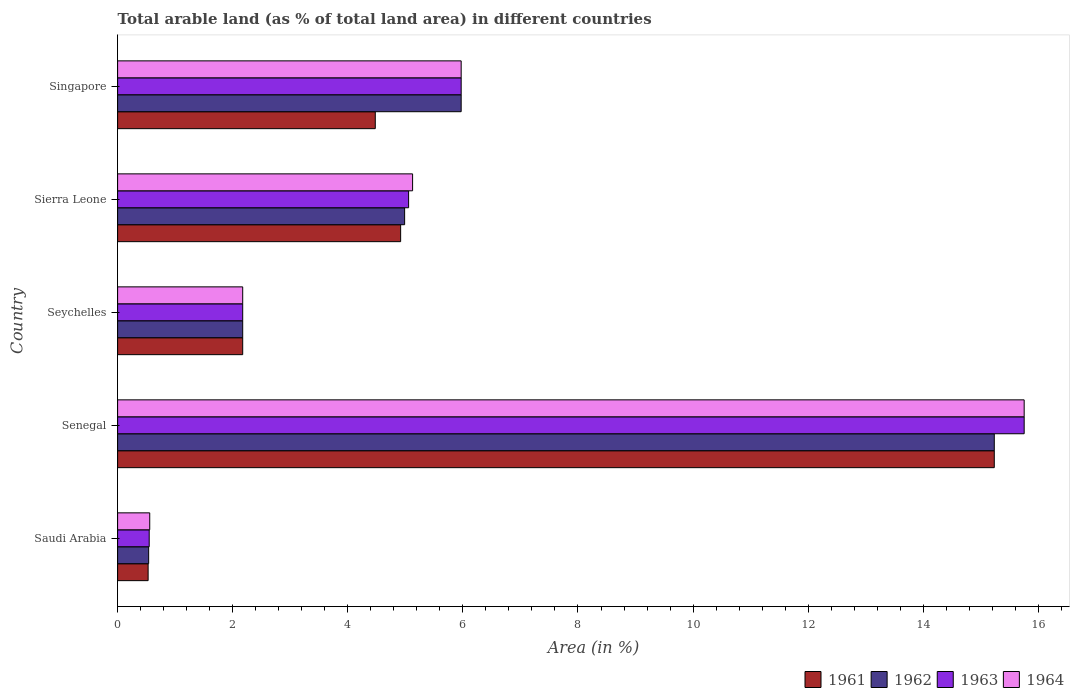How many different coloured bars are there?
Your answer should be compact. 4. Are the number of bars on each tick of the Y-axis equal?
Your answer should be compact. Yes. How many bars are there on the 1st tick from the bottom?
Provide a short and direct response. 4. What is the label of the 5th group of bars from the top?
Keep it short and to the point. Saudi Arabia. In how many cases, is the number of bars for a given country not equal to the number of legend labels?
Provide a succinct answer. 0. What is the percentage of arable land in 1962 in Saudi Arabia?
Your answer should be compact. 0.54. Across all countries, what is the maximum percentage of arable land in 1962?
Offer a very short reply. 15.23. Across all countries, what is the minimum percentage of arable land in 1961?
Offer a terse response. 0.53. In which country was the percentage of arable land in 1962 maximum?
Offer a very short reply. Senegal. In which country was the percentage of arable land in 1961 minimum?
Offer a very short reply. Saudi Arabia. What is the total percentage of arable land in 1964 in the graph?
Offer a very short reply. 29.58. What is the difference between the percentage of arable land in 1961 in Senegal and that in Singapore?
Your answer should be compact. 10.76. What is the difference between the percentage of arable land in 1961 in Senegal and the percentage of arable land in 1962 in Singapore?
Offer a terse response. 9.26. What is the average percentage of arable land in 1964 per country?
Your answer should be very brief. 5.92. What is the difference between the percentage of arable land in 1963 and percentage of arable land in 1964 in Senegal?
Offer a very short reply. 0. What is the ratio of the percentage of arable land in 1961 in Seychelles to that in Sierra Leone?
Offer a very short reply. 0.44. What is the difference between the highest and the second highest percentage of arable land in 1961?
Your answer should be compact. 10.32. What is the difference between the highest and the lowest percentage of arable land in 1964?
Keep it short and to the point. 15.2. Is the sum of the percentage of arable land in 1963 in Saudi Arabia and Seychelles greater than the maximum percentage of arable land in 1962 across all countries?
Offer a very short reply. No. What does the 1st bar from the bottom in Seychelles represents?
Ensure brevity in your answer.  1961. What is the difference between two consecutive major ticks on the X-axis?
Your answer should be very brief. 2. Does the graph contain any zero values?
Your answer should be compact. No. Does the graph contain grids?
Keep it short and to the point. No. Where does the legend appear in the graph?
Ensure brevity in your answer.  Bottom right. How many legend labels are there?
Give a very brief answer. 4. What is the title of the graph?
Offer a terse response. Total arable land (as % of total land area) in different countries. What is the label or title of the X-axis?
Your answer should be very brief. Area (in %). What is the Area (in %) in 1961 in Saudi Arabia?
Your answer should be very brief. 0.53. What is the Area (in %) in 1962 in Saudi Arabia?
Give a very brief answer. 0.54. What is the Area (in %) of 1963 in Saudi Arabia?
Offer a very short reply. 0.55. What is the Area (in %) of 1964 in Saudi Arabia?
Keep it short and to the point. 0.56. What is the Area (in %) in 1961 in Senegal?
Keep it short and to the point. 15.23. What is the Area (in %) of 1962 in Senegal?
Your answer should be very brief. 15.23. What is the Area (in %) in 1963 in Senegal?
Your response must be concise. 15.75. What is the Area (in %) in 1964 in Senegal?
Ensure brevity in your answer.  15.75. What is the Area (in %) of 1961 in Seychelles?
Give a very brief answer. 2.17. What is the Area (in %) of 1962 in Seychelles?
Your answer should be very brief. 2.17. What is the Area (in %) of 1963 in Seychelles?
Your answer should be very brief. 2.17. What is the Area (in %) of 1964 in Seychelles?
Your response must be concise. 2.17. What is the Area (in %) in 1961 in Sierra Leone?
Ensure brevity in your answer.  4.92. What is the Area (in %) in 1962 in Sierra Leone?
Provide a short and direct response. 4.99. What is the Area (in %) of 1963 in Sierra Leone?
Give a very brief answer. 5.06. What is the Area (in %) of 1964 in Sierra Leone?
Your answer should be very brief. 5.13. What is the Area (in %) of 1961 in Singapore?
Offer a very short reply. 4.48. What is the Area (in %) of 1962 in Singapore?
Make the answer very short. 5.97. What is the Area (in %) in 1963 in Singapore?
Provide a succinct answer. 5.97. What is the Area (in %) of 1964 in Singapore?
Provide a succinct answer. 5.97. Across all countries, what is the maximum Area (in %) in 1961?
Your response must be concise. 15.23. Across all countries, what is the maximum Area (in %) of 1962?
Keep it short and to the point. 15.23. Across all countries, what is the maximum Area (in %) in 1963?
Offer a terse response. 15.75. Across all countries, what is the maximum Area (in %) in 1964?
Your response must be concise. 15.75. Across all countries, what is the minimum Area (in %) of 1961?
Give a very brief answer. 0.53. Across all countries, what is the minimum Area (in %) in 1962?
Your answer should be very brief. 0.54. Across all countries, what is the minimum Area (in %) of 1963?
Give a very brief answer. 0.55. Across all countries, what is the minimum Area (in %) of 1964?
Your answer should be compact. 0.56. What is the total Area (in %) in 1961 in the graph?
Keep it short and to the point. 27.33. What is the total Area (in %) in 1962 in the graph?
Give a very brief answer. 28.91. What is the total Area (in %) in 1963 in the graph?
Your answer should be compact. 29.5. What is the total Area (in %) in 1964 in the graph?
Keep it short and to the point. 29.58. What is the difference between the Area (in %) of 1961 in Saudi Arabia and that in Senegal?
Offer a terse response. -14.7. What is the difference between the Area (in %) in 1962 in Saudi Arabia and that in Senegal?
Give a very brief answer. -14.69. What is the difference between the Area (in %) in 1963 in Saudi Arabia and that in Senegal?
Ensure brevity in your answer.  -15.2. What is the difference between the Area (in %) of 1964 in Saudi Arabia and that in Senegal?
Provide a succinct answer. -15.2. What is the difference between the Area (in %) of 1961 in Saudi Arabia and that in Seychelles?
Make the answer very short. -1.64. What is the difference between the Area (in %) of 1962 in Saudi Arabia and that in Seychelles?
Keep it short and to the point. -1.63. What is the difference between the Area (in %) in 1963 in Saudi Arabia and that in Seychelles?
Your answer should be very brief. -1.62. What is the difference between the Area (in %) of 1964 in Saudi Arabia and that in Seychelles?
Your answer should be very brief. -1.62. What is the difference between the Area (in %) of 1961 in Saudi Arabia and that in Sierra Leone?
Make the answer very short. -4.39. What is the difference between the Area (in %) in 1962 in Saudi Arabia and that in Sierra Leone?
Offer a terse response. -4.45. What is the difference between the Area (in %) of 1963 in Saudi Arabia and that in Sierra Leone?
Provide a succinct answer. -4.51. What is the difference between the Area (in %) of 1964 in Saudi Arabia and that in Sierra Leone?
Ensure brevity in your answer.  -4.57. What is the difference between the Area (in %) in 1961 in Saudi Arabia and that in Singapore?
Offer a terse response. -3.95. What is the difference between the Area (in %) of 1962 in Saudi Arabia and that in Singapore?
Provide a succinct answer. -5.43. What is the difference between the Area (in %) in 1963 in Saudi Arabia and that in Singapore?
Your response must be concise. -5.42. What is the difference between the Area (in %) of 1964 in Saudi Arabia and that in Singapore?
Your answer should be compact. -5.41. What is the difference between the Area (in %) of 1961 in Senegal and that in Seychelles?
Keep it short and to the point. 13.06. What is the difference between the Area (in %) in 1962 in Senegal and that in Seychelles?
Your answer should be compact. 13.06. What is the difference between the Area (in %) of 1963 in Senegal and that in Seychelles?
Offer a terse response. 13.58. What is the difference between the Area (in %) in 1964 in Senegal and that in Seychelles?
Your answer should be very brief. 13.58. What is the difference between the Area (in %) of 1961 in Senegal and that in Sierra Leone?
Offer a terse response. 10.32. What is the difference between the Area (in %) in 1962 in Senegal and that in Sierra Leone?
Provide a succinct answer. 10.25. What is the difference between the Area (in %) in 1963 in Senegal and that in Sierra Leone?
Provide a short and direct response. 10.7. What is the difference between the Area (in %) in 1964 in Senegal and that in Sierra Leone?
Ensure brevity in your answer.  10.63. What is the difference between the Area (in %) of 1961 in Senegal and that in Singapore?
Offer a terse response. 10.76. What is the difference between the Area (in %) of 1962 in Senegal and that in Singapore?
Ensure brevity in your answer.  9.26. What is the difference between the Area (in %) in 1963 in Senegal and that in Singapore?
Your answer should be very brief. 9.78. What is the difference between the Area (in %) in 1964 in Senegal and that in Singapore?
Your answer should be compact. 9.78. What is the difference between the Area (in %) in 1961 in Seychelles and that in Sierra Leone?
Offer a terse response. -2.74. What is the difference between the Area (in %) in 1962 in Seychelles and that in Sierra Leone?
Offer a very short reply. -2.81. What is the difference between the Area (in %) of 1963 in Seychelles and that in Sierra Leone?
Give a very brief answer. -2.88. What is the difference between the Area (in %) of 1964 in Seychelles and that in Sierra Leone?
Your response must be concise. -2.95. What is the difference between the Area (in %) in 1961 in Seychelles and that in Singapore?
Offer a terse response. -2.3. What is the difference between the Area (in %) of 1962 in Seychelles and that in Singapore?
Give a very brief answer. -3.8. What is the difference between the Area (in %) in 1963 in Seychelles and that in Singapore?
Keep it short and to the point. -3.8. What is the difference between the Area (in %) in 1964 in Seychelles and that in Singapore?
Your answer should be compact. -3.8. What is the difference between the Area (in %) of 1961 in Sierra Leone and that in Singapore?
Give a very brief answer. 0.44. What is the difference between the Area (in %) in 1962 in Sierra Leone and that in Singapore?
Make the answer very short. -0.98. What is the difference between the Area (in %) in 1963 in Sierra Leone and that in Singapore?
Keep it short and to the point. -0.91. What is the difference between the Area (in %) in 1964 in Sierra Leone and that in Singapore?
Offer a very short reply. -0.84. What is the difference between the Area (in %) in 1961 in Saudi Arabia and the Area (in %) in 1962 in Senegal?
Your response must be concise. -14.7. What is the difference between the Area (in %) of 1961 in Saudi Arabia and the Area (in %) of 1963 in Senegal?
Offer a very short reply. -15.22. What is the difference between the Area (in %) in 1961 in Saudi Arabia and the Area (in %) in 1964 in Senegal?
Make the answer very short. -15.22. What is the difference between the Area (in %) in 1962 in Saudi Arabia and the Area (in %) in 1963 in Senegal?
Your response must be concise. -15.21. What is the difference between the Area (in %) in 1962 in Saudi Arabia and the Area (in %) in 1964 in Senegal?
Give a very brief answer. -15.21. What is the difference between the Area (in %) in 1963 in Saudi Arabia and the Area (in %) in 1964 in Senegal?
Offer a very short reply. -15.2. What is the difference between the Area (in %) of 1961 in Saudi Arabia and the Area (in %) of 1962 in Seychelles?
Your answer should be compact. -1.64. What is the difference between the Area (in %) of 1961 in Saudi Arabia and the Area (in %) of 1963 in Seychelles?
Ensure brevity in your answer.  -1.64. What is the difference between the Area (in %) of 1961 in Saudi Arabia and the Area (in %) of 1964 in Seychelles?
Make the answer very short. -1.64. What is the difference between the Area (in %) of 1962 in Saudi Arabia and the Area (in %) of 1963 in Seychelles?
Keep it short and to the point. -1.63. What is the difference between the Area (in %) of 1962 in Saudi Arabia and the Area (in %) of 1964 in Seychelles?
Provide a succinct answer. -1.63. What is the difference between the Area (in %) of 1963 in Saudi Arabia and the Area (in %) of 1964 in Seychelles?
Provide a succinct answer. -1.62. What is the difference between the Area (in %) of 1961 in Saudi Arabia and the Area (in %) of 1962 in Sierra Leone?
Offer a terse response. -4.46. What is the difference between the Area (in %) of 1961 in Saudi Arabia and the Area (in %) of 1963 in Sierra Leone?
Your answer should be very brief. -4.53. What is the difference between the Area (in %) in 1961 in Saudi Arabia and the Area (in %) in 1964 in Sierra Leone?
Offer a terse response. -4.6. What is the difference between the Area (in %) of 1962 in Saudi Arabia and the Area (in %) of 1963 in Sierra Leone?
Offer a terse response. -4.52. What is the difference between the Area (in %) in 1962 in Saudi Arabia and the Area (in %) in 1964 in Sierra Leone?
Make the answer very short. -4.59. What is the difference between the Area (in %) in 1963 in Saudi Arabia and the Area (in %) in 1964 in Sierra Leone?
Give a very brief answer. -4.58. What is the difference between the Area (in %) of 1961 in Saudi Arabia and the Area (in %) of 1962 in Singapore?
Your answer should be very brief. -5.44. What is the difference between the Area (in %) in 1961 in Saudi Arabia and the Area (in %) in 1963 in Singapore?
Make the answer very short. -5.44. What is the difference between the Area (in %) of 1961 in Saudi Arabia and the Area (in %) of 1964 in Singapore?
Your answer should be very brief. -5.44. What is the difference between the Area (in %) in 1962 in Saudi Arabia and the Area (in %) in 1963 in Singapore?
Ensure brevity in your answer.  -5.43. What is the difference between the Area (in %) of 1962 in Saudi Arabia and the Area (in %) of 1964 in Singapore?
Ensure brevity in your answer.  -5.43. What is the difference between the Area (in %) of 1963 in Saudi Arabia and the Area (in %) of 1964 in Singapore?
Make the answer very short. -5.42. What is the difference between the Area (in %) in 1961 in Senegal and the Area (in %) in 1962 in Seychelles?
Give a very brief answer. 13.06. What is the difference between the Area (in %) in 1961 in Senegal and the Area (in %) in 1963 in Seychelles?
Make the answer very short. 13.06. What is the difference between the Area (in %) of 1961 in Senegal and the Area (in %) of 1964 in Seychelles?
Provide a short and direct response. 13.06. What is the difference between the Area (in %) of 1962 in Senegal and the Area (in %) of 1963 in Seychelles?
Provide a succinct answer. 13.06. What is the difference between the Area (in %) of 1962 in Senegal and the Area (in %) of 1964 in Seychelles?
Your response must be concise. 13.06. What is the difference between the Area (in %) in 1963 in Senegal and the Area (in %) in 1964 in Seychelles?
Your answer should be very brief. 13.58. What is the difference between the Area (in %) in 1961 in Senegal and the Area (in %) in 1962 in Sierra Leone?
Your answer should be very brief. 10.25. What is the difference between the Area (in %) in 1961 in Senegal and the Area (in %) in 1963 in Sierra Leone?
Your answer should be very brief. 10.18. What is the difference between the Area (in %) of 1961 in Senegal and the Area (in %) of 1964 in Sierra Leone?
Offer a terse response. 10.11. What is the difference between the Area (in %) in 1962 in Senegal and the Area (in %) in 1963 in Sierra Leone?
Your answer should be compact. 10.18. What is the difference between the Area (in %) of 1962 in Senegal and the Area (in %) of 1964 in Sierra Leone?
Keep it short and to the point. 10.11. What is the difference between the Area (in %) of 1963 in Senegal and the Area (in %) of 1964 in Sierra Leone?
Ensure brevity in your answer.  10.63. What is the difference between the Area (in %) in 1961 in Senegal and the Area (in %) in 1962 in Singapore?
Your answer should be compact. 9.26. What is the difference between the Area (in %) of 1961 in Senegal and the Area (in %) of 1963 in Singapore?
Offer a very short reply. 9.26. What is the difference between the Area (in %) in 1961 in Senegal and the Area (in %) in 1964 in Singapore?
Make the answer very short. 9.26. What is the difference between the Area (in %) in 1962 in Senegal and the Area (in %) in 1963 in Singapore?
Keep it short and to the point. 9.26. What is the difference between the Area (in %) in 1962 in Senegal and the Area (in %) in 1964 in Singapore?
Your answer should be very brief. 9.26. What is the difference between the Area (in %) of 1963 in Senegal and the Area (in %) of 1964 in Singapore?
Give a very brief answer. 9.78. What is the difference between the Area (in %) of 1961 in Seychelles and the Area (in %) of 1962 in Sierra Leone?
Ensure brevity in your answer.  -2.81. What is the difference between the Area (in %) in 1961 in Seychelles and the Area (in %) in 1963 in Sierra Leone?
Give a very brief answer. -2.88. What is the difference between the Area (in %) in 1961 in Seychelles and the Area (in %) in 1964 in Sierra Leone?
Your response must be concise. -2.95. What is the difference between the Area (in %) of 1962 in Seychelles and the Area (in %) of 1963 in Sierra Leone?
Ensure brevity in your answer.  -2.88. What is the difference between the Area (in %) in 1962 in Seychelles and the Area (in %) in 1964 in Sierra Leone?
Offer a very short reply. -2.95. What is the difference between the Area (in %) in 1963 in Seychelles and the Area (in %) in 1964 in Sierra Leone?
Your answer should be compact. -2.95. What is the difference between the Area (in %) of 1961 in Seychelles and the Area (in %) of 1962 in Singapore?
Ensure brevity in your answer.  -3.8. What is the difference between the Area (in %) in 1961 in Seychelles and the Area (in %) in 1963 in Singapore?
Your response must be concise. -3.8. What is the difference between the Area (in %) of 1961 in Seychelles and the Area (in %) of 1964 in Singapore?
Keep it short and to the point. -3.8. What is the difference between the Area (in %) of 1962 in Seychelles and the Area (in %) of 1963 in Singapore?
Make the answer very short. -3.8. What is the difference between the Area (in %) of 1962 in Seychelles and the Area (in %) of 1964 in Singapore?
Keep it short and to the point. -3.8. What is the difference between the Area (in %) in 1963 in Seychelles and the Area (in %) in 1964 in Singapore?
Your response must be concise. -3.8. What is the difference between the Area (in %) of 1961 in Sierra Leone and the Area (in %) of 1962 in Singapore?
Your answer should be compact. -1.05. What is the difference between the Area (in %) of 1961 in Sierra Leone and the Area (in %) of 1963 in Singapore?
Make the answer very short. -1.05. What is the difference between the Area (in %) in 1961 in Sierra Leone and the Area (in %) in 1964 in Singapore?
Provide a short and direct response. -1.05. What is the difference between the Area (in %) of 1962 in Sierra Leone and the Area (in %) of 1963 in Singapore?
Provide a short and direct response. -0.98. What is the difference between the Area (in %) in 1962 in Sierra Leone and the Area (in %) in 1964 in Singapore?
Offer a very short reply. -0.98. What is the difference between the Area (in %) of 1963 in Sierra Leone and the Area (in %) of 1964 in Singapore?
Provide a short and direct response. -0.91. What is the average Area (in %) of 1961 per country?
Ensure brevity in your answer.  5.47. What is the average Area (in %) in 1962 per country?
Ensure brevity in your answer.  5.78. What is the average Area (in %) in 1963 per country?
Offer a terse response. 5.9. What is the average Area (in %) of 1964 per country?
Provide a short and direct response. 5.92. What is the difference between the Area (in %) in 1961 and Area (in %) in 1962 in Saudi Arabia?
Keep it short and to the point. -0.01. What is the difference between the Area (in %) of 1961 and Area (in %) of 1963 in Saudi Arabia?
Ensure brevity in your answer.  -0.02. What is the difference between the Area (in %) in 1961 and Area (in %) in 1964 in Saudi Arabia?
Your answer should be very brief. -0.03. What is the difference between the Area (in %) of 1962 and Area (in %) of 1963 in Saudi Arabia?
Offer a very short reply. -0.01. What is the difference between the Area (in %) of 1962 and Area (in %) of 1964 in Saudi Arabia?
Provide a short and direct response. -0.02. What is the difference between the Area (in %) in 1963 and Area (in %) in 1964 in Saudi Arabia?
Give a very brief answer. -0.01. What is the difference between the Area (in %) in 1961 and Area (in %) in 1963 in Senegal?
Ensure brevity in your answer.  -0.52. What is the difference between the Area (in %) of 1961 and Area (in %) of 1964 in Senegal?
Your answer should be compact. -0.52. What is the difference between the Area (in %) of 1962 and Area (in %) of 1963 in Senegal?
Offer a very short reply. -0.52. What is the difference between the Area (in %) in 1962 and Area (in %) in 1964 in Senegal?
Provide a short and direct response. -0.52. What is the difference between the Area (in %) in 1962 and Area (in %) in 1963 in Seychelles?
Offer a terse response. 0. What is the difference between the Area (in %) of 1962 and Area (in %) of 1964 in Seychelles?
Keep it short and to the point. 0. What is the difference between the Area (in %) of 1961 and Area (in %) of 1962 in Sierra Leone?
Your response must be concise. -0.07. What is the difference between the Area (in %) of 1961 and Area (in %) of 1963 in Sierra Leone?
Offer a very short reply. -0.14. What is the difference between the Area (in %) in 1961 and Area (in %) in 1964 in Sierra Leone?
Offer a terse response. -0.21. What is the difference between the Area (in %) of 1962 and Area (in %) of 1963 in Sierra Leone?
Provide a succinct answer. -0.07. What is the difference between the Area (in %) of 1962 and Area (in %) of 1964 in Sierra Leone?
Offer a very short reply. -0.14. What is the difference between the Area (in %) of 1963 and Area (in %) of 1964 in Sierra Leone?
Offer a terse response. -0.07. What is the difference between the Area (in %) in 1961 and Area (in %) in 1962 in Singapore?
Give a very brief answer. -1.49. What is the difference between the Area (in %) of 1961 and Area (in %) of 1963 in Singapore?
Make the answer very short. -1.49. What is the difference between the Area (in %) in 1961 and Area (in %) in 1964 in Singapore?
Your answer should be very brief. -1.49. What is the ratio of the Area (in %) in 1961 in Saudi Arabia to that in Senegal?
Make the answer very short. 0.03. What is the ratio of the Area (in %) of 1962 in Saudi Arabia to that in Senegal?
Your response must be concise. 0.04. What is the ratio of the Area (in %) in 1963 in Saudi Arabia to that in Senegal?
Your answer should be very brief. 0.03. What is the ratio of the Area (in %) in 1964 in Saudi Arabia to that in Senegal?
Your response must be concise. 0.04. What is the ratio of the Area (in %) in 1961 in Saudi Arabia to that in Seychelles?
Your answer should be compact. 0.24. What is the ratio of the Area (in %) of 1962 in Saudi Arabia to that in Seychelles?
Provide a short and direct response. 0.25. What is the ratio of the Area (in %) in 1963 in Saudi Arabia to that in Seychelles?
Your response must be concise. 0.25. What is the ratio of the Area (in %) in 1964 in Saudi Arabia to that in Seychelles?
Your response must be concise. 0.26. What is the ratio of the Area (in %) in 1961 in Saudi Arabia to that in Sierra Leone?
Keep it short and to the point. 0.11. What is the ratio of the Area (in %) in 1962 in Saudi Arabia to that in Sierra Leone?
Keep it short and to the point. 0.11. What is the ratio of the Area (in %) in 1963 in Saudi Arabia to that in Sierra Leone?
Provide a succinct answer. 0.11. What is the ratio of the Area (in %) of 1964 in Saudi Arabia to that in Sierra Leone?
Make the answer very short. 0.11. What is the ratio of the Area (in %) of 1961 in Saudi Arabia to that in Singapore?
Keep it short and to the point. 0.12. What is the ratio of the Area (in %) of 1962 in Saudi Arabia to that in Singapore?
Keep it short and to the point. 0.09. What is the ratio of the Area (in %) of 1963 in Saudi Arabia to that in Singapore?
Make the answer very short. 0.09. What is the ratio of the Area (in %) in 1964 in Saudi Arabia to that in Singapore?
Make the answer very short. 0.09. What is the ratio of the Area (in %) of 1961 in Senegal to that in Seychelles?
Make the answer very short. 7.01. What is the ratio of the Area (in %) of 1962 in Senegal to that in Seychelles?
Make the answer very short. 7.01. What is the ratio of the Area (in %) in 1963 in Senegal to that in Seychelles?
Your answer should be very brief. 7.25. What is the ratio of the Area (in %) in 1964 in Senegal to that in Seychelles?
Keep it short and to the point. 7.25. What is the ratio of the Area (in %) of 1961 in Senegal to that in Sierra Leone?
Provide a short and direct response. 3.1. What is the ratio of the Area (in %) in 1962 in Senegal to that in Sierra Leone?
Make the answer very short. 3.05. What is the ratio of the Area (in %) in 1963 in Senegal to that in Sierra Leone?
Offer a terse response. 3.12. What is the ratio of the Area (in %) in 1964 in Senegal to that in Sierra Leone?
Give a very brief answer. 3.07. What is the ratio of the Area (in %) of 1961 in Senegal to that in Singapore?
Keep it short and to the point. 3.4. What is the ratio of the Area (in %) in 1962 in Senegal to that in Singapore?
Provide a succinct answer. 2.55. What is the ratio of the Area (in %) of 1963 in Senegal to that in Singapore?
Provide a succinct answer. 2.64. What is the ratio of the Area (in %) of 1964 in Senegal to that in Singapore?
Keep it short and to the point. 2.64. What is the ratio of the Area (in %) in 1961 in Seychelles to that in Sierra Leone?
Provide a short and direct response. 0.44. What is the ratio of the Area (in %) in 1962 in Seychelles to that in Sierra Leone?
Provide a succinct answer. 0.44. What is the ratio of the Area (in %) of 1963 in Seychelles to that in Sierra Leone?
Your answer should be very brief. 0.43. What is the ratio of the Area (in %) in 1964 in Seychelles to that in Sierra Leone?
Ensure brevity in your answer.  0.42. What is the ratio of the Area (in %) in 1961 in Seychelles to that in Singapore?
Provide a short and direct response. 0.49. What is the ratio of the Area (in %) in 1962 in Seychelles to that in Singapore?
Offer a terse response. 0.36. What is the ratio of the Area (in %) in 1963 in Seychelles to that in Singapore?
Give a very brief answer. 0.36. What is the ratio of the Area (in %) of 1964 in Seychelles to that in Singapore?
Your response must be concise. 0.36. What is the ratio of the Area (in %) of 1961 in Sierra Leone to that in Singapore?
Make the answer very short. 1.1. What is the ratio of the Area (in %) of 1962 in Sierra Leone to that in Singapore?
Give a very brief answer. 0.84. What is the ratio of the Area (in %) in 1963 in Sierra Leone to that in Singapore?
Give a very brief answer. 0.85. What is the ratio of the Area (in %) of 1964 in Sierra Leone to that in Singapore?
Provide a short and direct response. 0.86. What is the difference between the highest and the second highest Area (in %) of 1961?
Provide a succinct answer. 10.32. What is the difference between the highest and the second highest Area (in %) of 1962?
Your response must be concise. 9.26. What is the difference between the highest and the second highest Area (in %) in 1963?
Your answer should be very brief. 9.78. What is the difference between the highest and the second highest Area (in %) in 1964?
Ensure brevity in your answer.  9.78. What is the difference between the highest and the lowest Area (in %) in 1961?
Make the answer very short. 14.7. What is the difference between the highest and the lowest Area (in %) of 1962?
Keep it short and to the point. 14.69. What is the difference between the highest and the lowest Area (in %) in 1963?
Provide a succinct answer. 15.2. What is the difference between the highest and the lowest Area (in %) of 1964?
Your answer should be very brief. 15.2. 